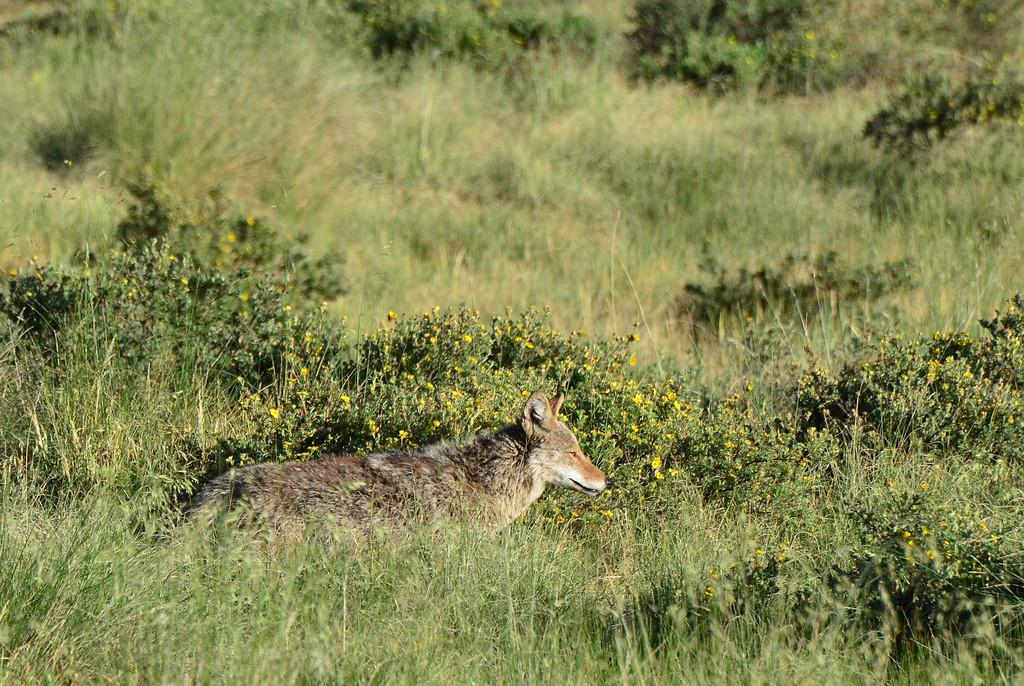What type of vegetation can be seen in the image? There is grass and flower plants in the image. What else is present in the image besides vegetation? There is an animal in the image. What type of feather can be seen on the animal in the image? There is no feather visible on the animal in the image. How much debt does the animal owe in the image? There is no mention of debt in the image, and the animal does not appear to be involved in any financial transactions. 